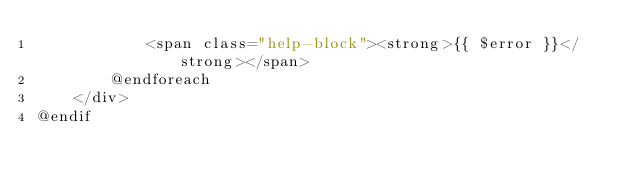<code> <loc_0><loc_0><loc_500><loc_500><_PHP_>            <span class="help-block"><strong>{{ $error }}</strong></span>
        @endforeach
    </div>
@endif</code> 